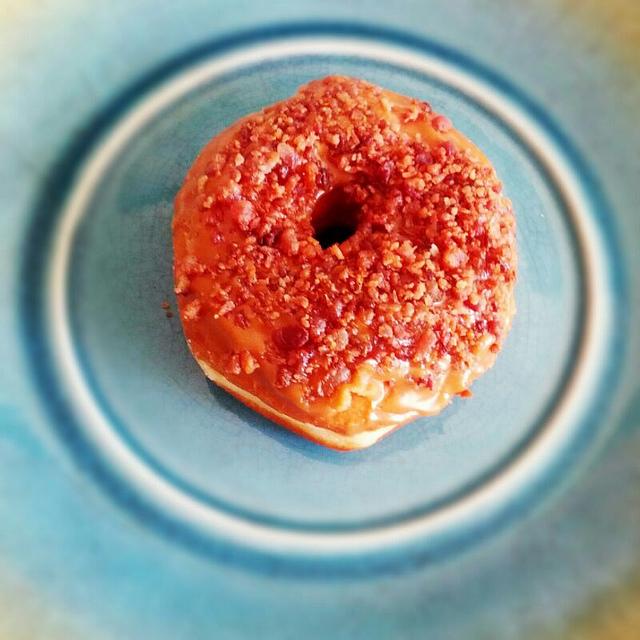What flavor is this doughnut?
Answer briefly. Bacon. Is the plate upside down?
Keep it brief. Yes. Does this donut have sprinkles on it?
Concise answer only. Yes. Where is the blue plate?
Quick response, please. Under doughnut. What food is on this plate?
Answer briefly. Donut. 